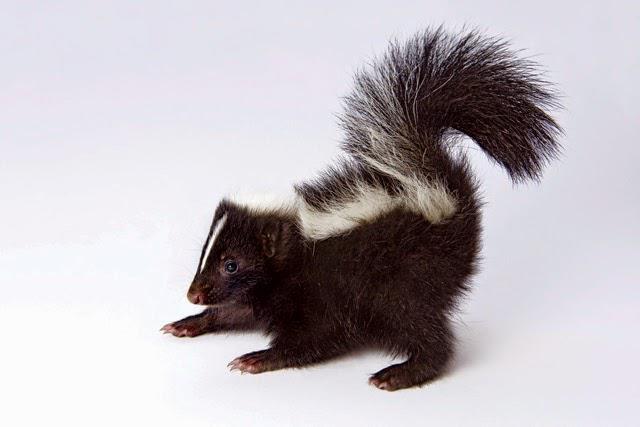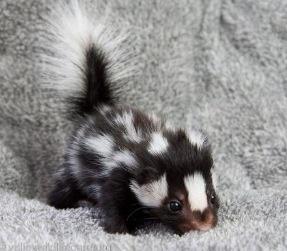The first image is the image on the left, the second image is the image on the right. Given the left and right images, does the statement "Only two young skunks are shown and no other animals are visible." hold true? Answer yes or no. Yes. The first image is the image on the left, the second image is the image on the right. Examine the images to the left and right. Is the description "There are just two skunks and no other animals." accurate? Answer yes or no. Yes. 